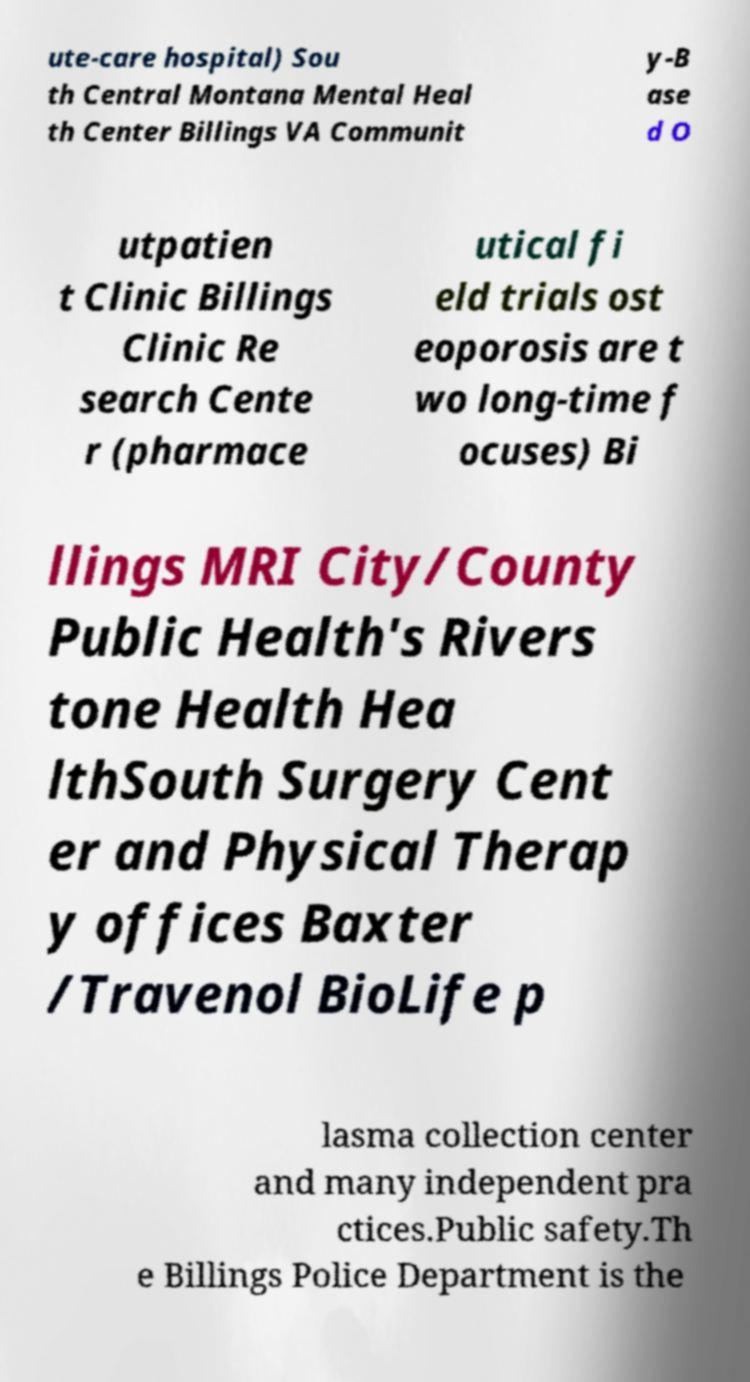Can you read and provide the text displayed in the image?This photo seems to have some interesting text. Can you extract and type it out for me? ute-care hospital) Sou th Central Montana Mental Heal th Center Billings VA Communit y-B ase d O utpatien t Clinic Billings Clinic Re search Cente r (pharmace utical fi eld trials ost eoporosis are t wo long-time f ocuses) Bi llings MRI City/County Public Health's Rivers tone Health Hea lthSouth Surgery Cent er and Physical Therap y offices Baxter /Travenol BioLife p lasma collection center and many independent pra ctices.Public safety.Th e Billings Police Department is the 